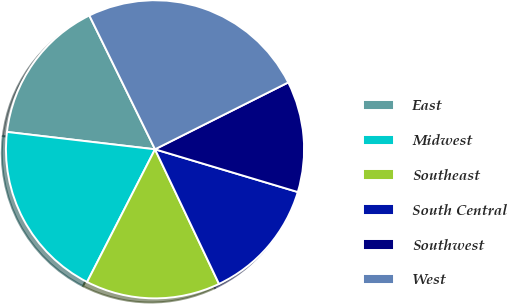Convert chart to OTSL. <chart><loc_0><loc_0><loc_500><loc_500><pie_chart><fcel>East<fcel>Midwest<fcel>Southeast<fcel>South Central<fcel>Southwest<fcel>West<nl><fcel>15.88%<fcel>19.33%<fcel>14.59%<fcel>13.31%<fcel>12.03%<fcel>24.86%<nl></chart> 